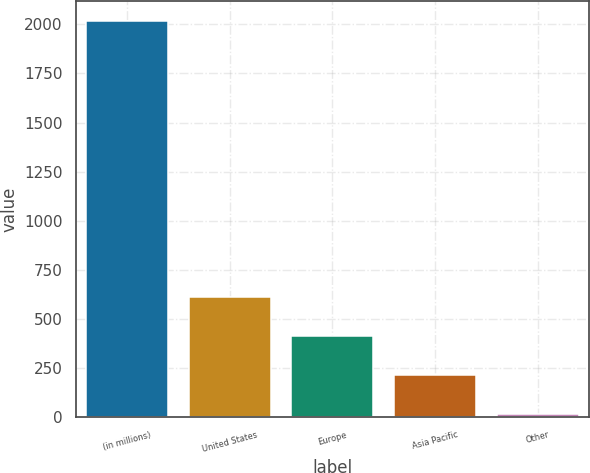Convert chart. <chart><loc_0><loc_0><loc_500><loc_500><bar_chart><fcel>(in millions)<fcel>United States<fcel>Europe<fcel>Asia Pacific<fcel>Other<nl><fcel>2016<fcel>613.9<fcel>413.6<fcel>213.3<fcel>13<nl></chart> 